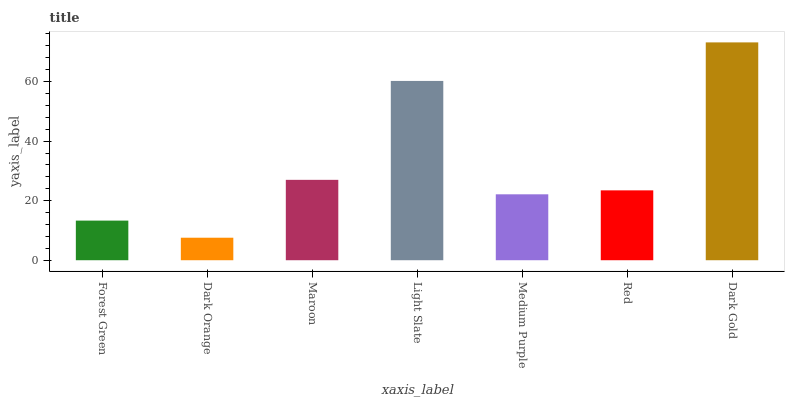Is Dark Orange the minimum?
Answer yes or no. Yes. Is Dark Gold the maximum?
Answer yes or no. Yes. Is Maroon the minimum?
Answer yes or no. No. Is Maroon the maximum?
Answer yes or no. No. Is Maroon greater than Dark Orange?
Answer yes or no. Yes. Is Dark Orange less than Maroon?
Answer yes or no. Yes. Is Dark Orange greater than Maroon?
Answer yes or no. No. Is Maroon less than Dark Orange?
Answer yes or no. No. Is Red the high median?
Answer yes or no. Yes. Is Red the low median?
Answer yes or no. Yes. Is Forest Green the high median?
Answer yes or no. No. Is Dark Orange the low median?
Answer yes or no. No. 